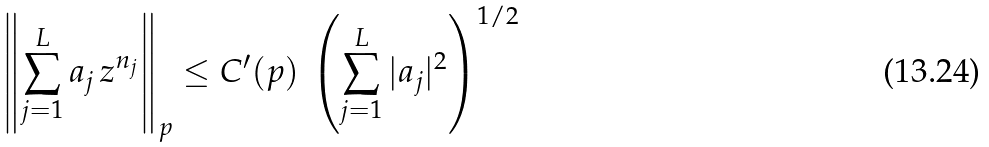<formula> <loc_0><loc_0><loc_500><loc_500>\left \| \sum _ { j = 1 } ^ { L } a _ { j } \, z ^ { n _ { j } } \right \| _ { p } \leq C ^ { \prime } ( p ) \, \left ( \sum _ { j = 1 } ^ { L } | a _ { j } | ^ { 2 } \right ) ^ { 1 / 2 }</formula> 